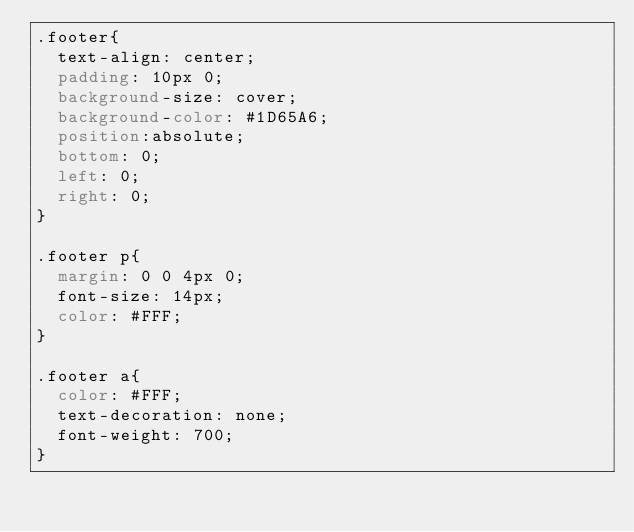Convert code to text. <code><loc_0><loc_0><loc_500><loc_500><_CSS_>.footer{
  text-align: center;
  padding: 10px 0;
  background-size: cover;
  background-color: #1D65A6;
  position:absolute;
  bottom: 0;
  left: 0;
  right: 0;
}

.footer p{
  margin: 0 0 4px 0;
  font-size: 14px;
  color: #FFF;
}

.footer a{
  color: #FFF;
  text-decoration: none;
  font-weight: 700;
}
</code> 